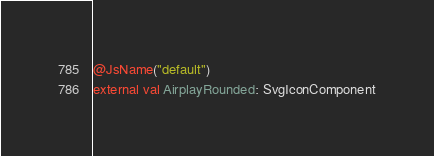<code> <loc_0><loc_0><loc_500><loc_500><_Kotlin_>@JsName("default")
external val AirplayRounded: SvgIconComponent
</code> 